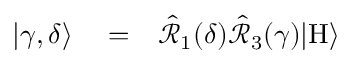Convert formula to latex. <formula><loc_0><loc_0><loc_500><loc_500>\begin{array} { r l r } { | \gamma , \delta \rangle } & = } & { \hat { \mathcal { R } } _ { 1 } ( \delta ) \hat { \mathcal { R } } _ { 3 } ( \gamma ) | H \rangle } \end{array}</formula> 